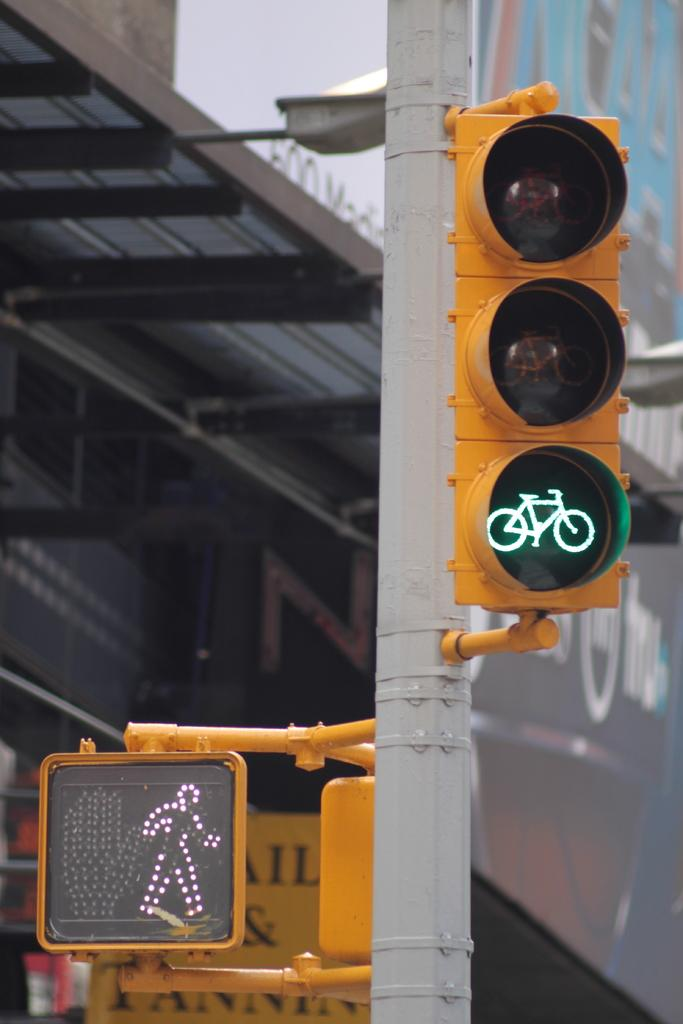<image>
Relay a brief, clear account of the picture shown. A crosswalk shows that people can safely walk and that bicycles can also proceed. 